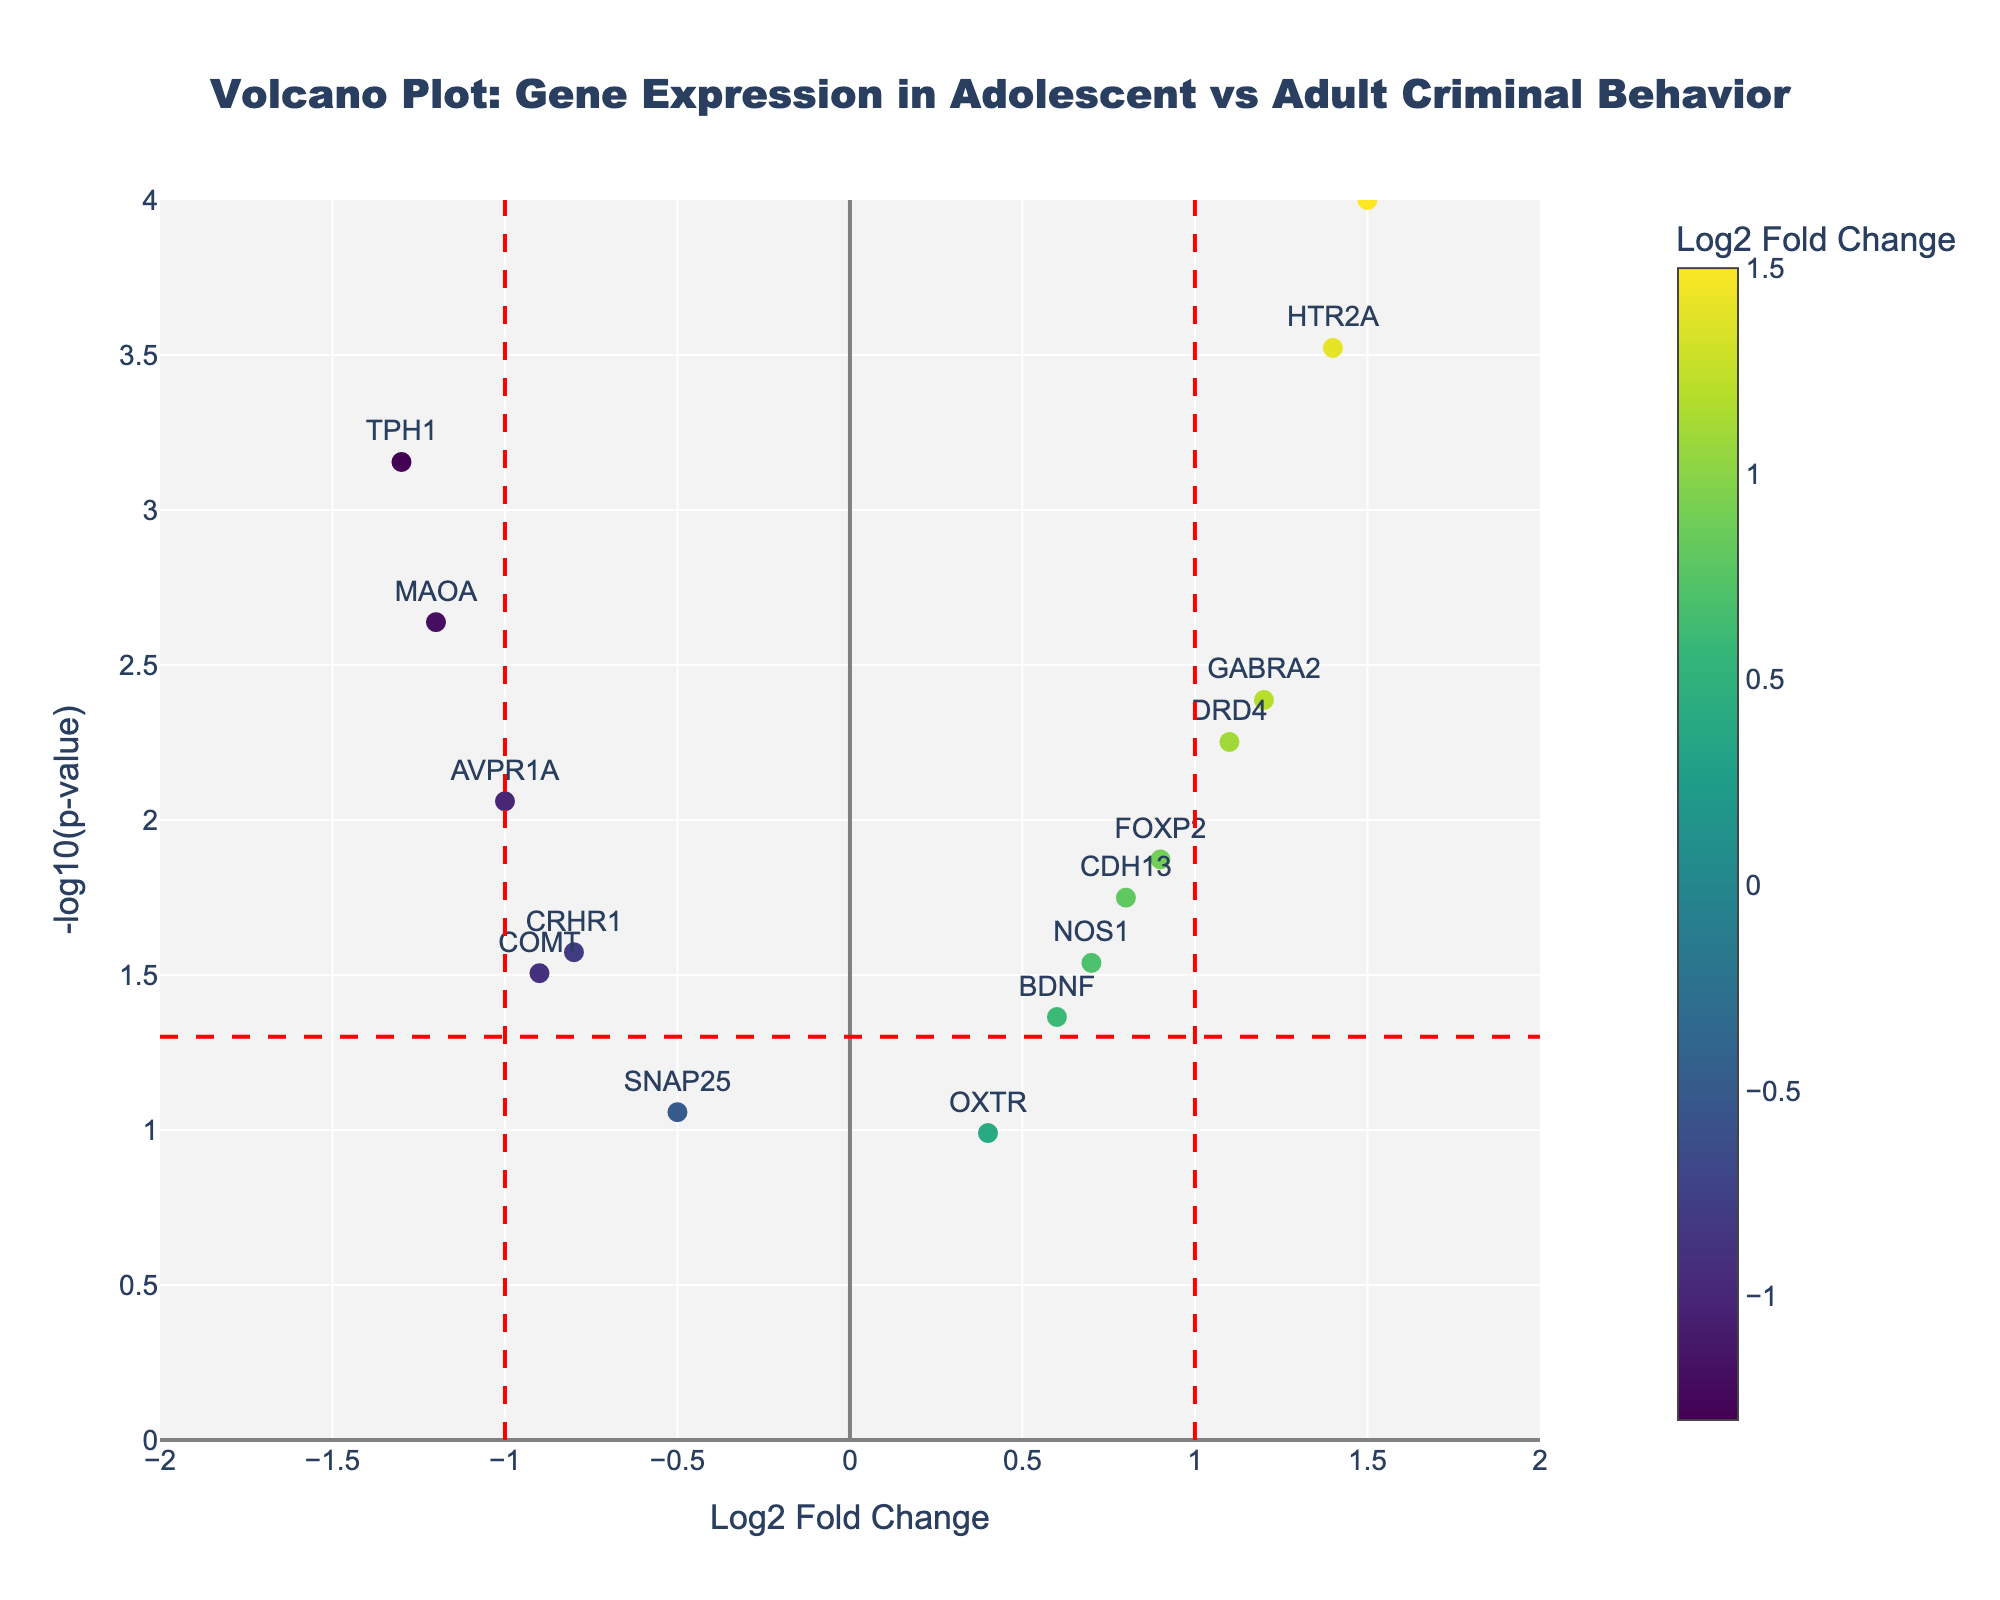How many genes have a Log2 Fold Change (Log2FC) greater than 1? To identify the genes with a Log2FC greater than 1, look at the x-axis values and count the points to the right of the vertical red line at x = 1. These genes are SLC6A4, DRD4, HTR2A, and GABRA2.
Answer: 4 What gene has the lowest p-value? The lowest p-value corresponds to the highest -log10(p-value) on the y-axis. The gene at the highest y-axis position is SLC6A4.
Answer: SLC6A4 Which gene has the most significant negative Log2 Fold Change? For the most significant negative Log2FC, look for the point farthest to the left on the x-axis. TPH1 has the lowest Log2FC at -1.3.
Answer: TPH1 How many genes are significantly differentially expressed (p-value < 0.05)? To find the significantly differentially expressed genes, count the points above the horizontal red line indicating y = -log10(0.05). These genes are MAOA, CDH13, SLC6A4, COMT, DRD4, BDNF, TPH1, NOS1, GABRA2, FOXP2, AVPR1A, and CRHR1.
Answer: 12 Which gene has the smallest change in expression (close to 0 Log2FC)? The gene closest to 0 on the x-axis represents the smallest change in expression. Here, the closest gene is OXTR.
Answer: OXTR How many genes have a -log10(p-value) greater than 3? Genes with a -log10(p-value) greater than 3 will be those above the y = 3 mark on the y-axis. We see two genes in this range: SLC6A4 and HTR2A.
Answer: 2 Are there more upregulated or downregulated genes? Count the upregulated genes (positive Log2FC, right side of x=0) and downregulated genes (negative Log2FC, left side of x=0). There are 8 genes with positive Log2FC and 6 genes with negative Log2FC.
Answer: More upregulated Which gene has the highest Log2 Fold Change and what is its p-value? Identify the gene with the highest Log2FC by looking to the far right on the x-axis, which is SLC6A4, then refer to the hovertext or y-coordinate for its p-value.
Answer: SLC6A4, 0.0001 What is the Log2 Fold Change of COMT and its significance level (is it above or below the threshold)? Find COMT on the plot and read the Log2FC (x) and -log10(p-value) (y). COMT has a Log2FC of -0.9 and is below the significance threshold as its -log10(p-value) is less than -log10(0.05).
Answer: -0.9, below What is the range of -log10(p-value) for these genes? The range of -log10(p-value) is determined by the smallest and largest values seen on the y-axis. The minimum is just above 0 for OXTR, and the maximum is around 4 for SLC6A4 and HTR2A.
Answer: 0 to 4 